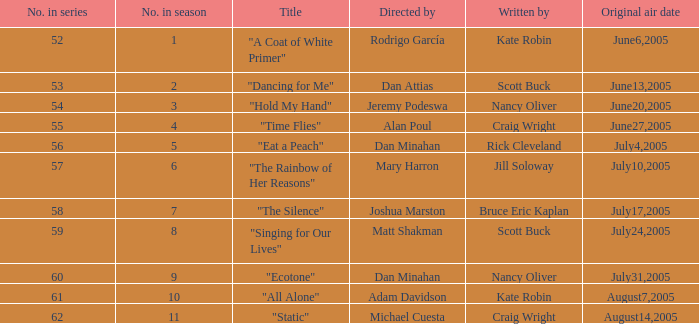Can you give me this table as a dict? {'header': ['No. in series', 'No. in season', 'Title', 'Directed by', 'Written by', 'Original air date'], 'rows': [['52', '1', '"A Coat of White Primer"', 'Rodrigo García', 'Kate Robin', 'June6,2005'], ['53', '2', '"Dancing for Me"', 'Dan Attias', 'Scott Buck', 'June13,2005'], ['54', '3', '"Hold My Hand"', 'Jeremy Podeswa', 'Nancy Oliver', 'June20,2005'], ['55', '4', '"Time Flies"', 'Alan Poul', 'Craig Wright', 'June27,2005'], ['56', '5', '"Eat a Peach"', 'Dan Minahan', 'Rick Cleveland', 'July4,2005'], ['57', '6', '"The Rainbow of Her Reasons"', 'Mary Harron', 'Jill Soloway', 'July10,2005'], ['58', '7', '"The Silence"', 'Joshua Marston', 'Bruce Eric Kaplan', 'July17,2005'], ['59', '8', '"Singing for Our Lives"', 'Matt Shakman', 'Scott Buck', 'July24,2005'], ['60', '9', '"Ecotone"', 'Dan Minahan', 'Nancy Oliver', 'July31,2005'], ['61', '10', '"All Alone"', 'Adam Davidson', 'Kate Robin', 'August7,2005'], ['62', '11', '"Static"', 'Michael Cuesta', 'Craig Wright', 'August14,2005']]} Which episode directed by mary harron is being referred to by its name? "The Rainbow of Her Reasons". 